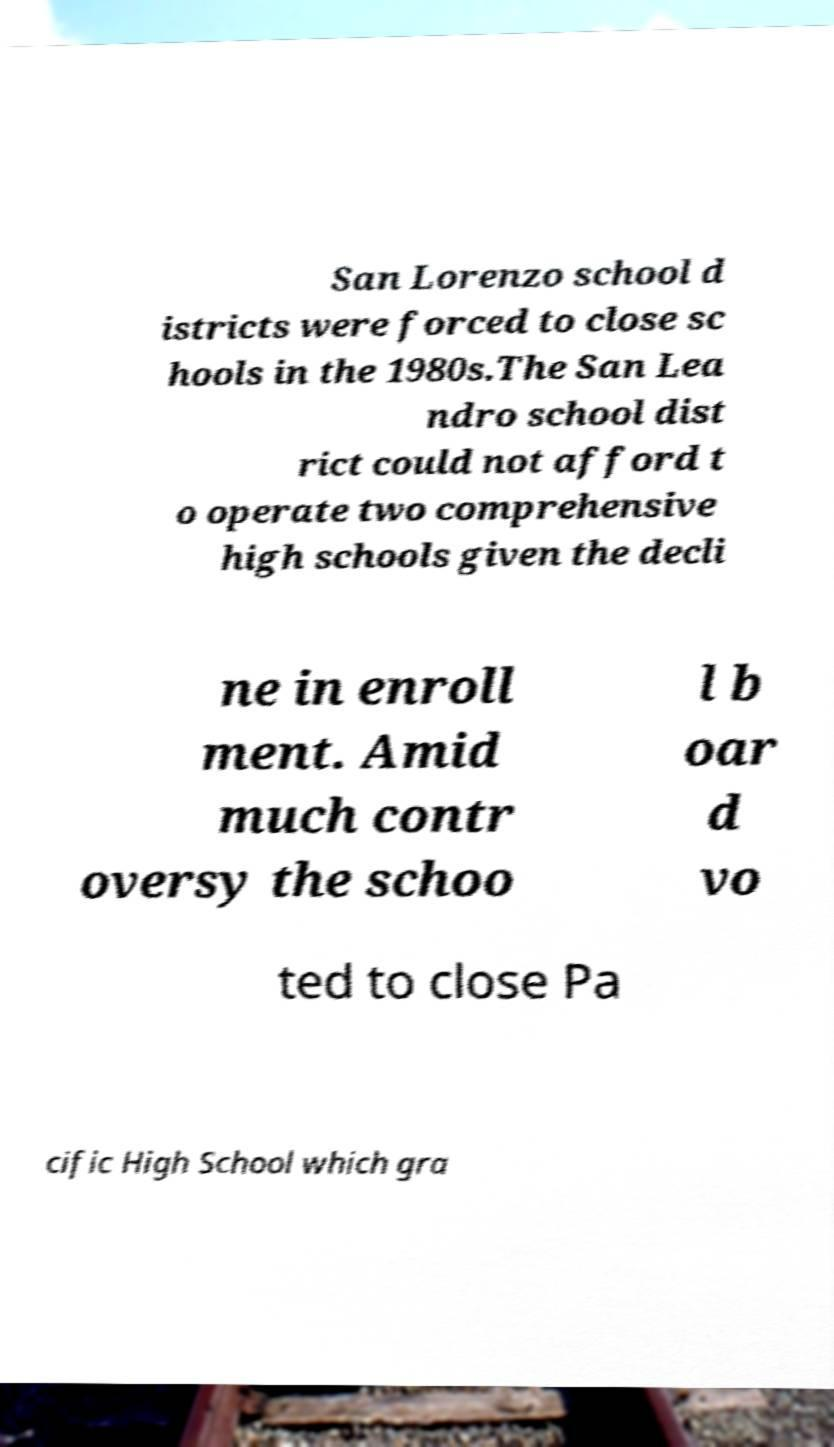Could you assist in decoding the text presented in this image and type it out clearly? San Lorenzo school d istricts were forced to close sc hools in the 1980s.The San Lea ndro school dist rict could not afford t o operate two comprehensive high schools given the decli ne in enroll ment. Amid much contr oversy the schoo l b oar d vo ted to close Pa cific High School which gra 